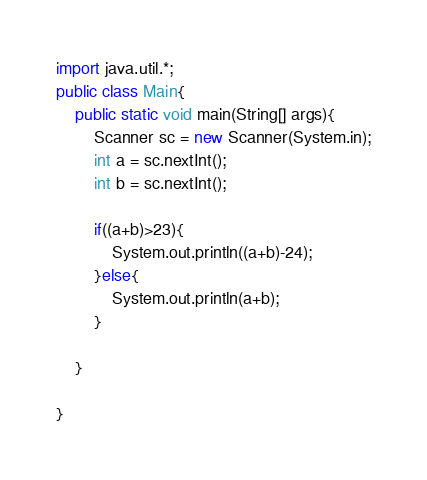Convert code to text. <code><loc_0><loc_0><loc_500><loc_500><_Java_>import java.util.*;
public class Main{
    public static void main(String[] args){
        Scanner sc = new Scanner(System.in);
        int a = sc.nextInt();
        int b = sc.nextInt();

        if((a+b)>23){
            System.out.println((a+b)-24);
        }else{
            System.out.println(a+b);
        }

    }

}
</code> 